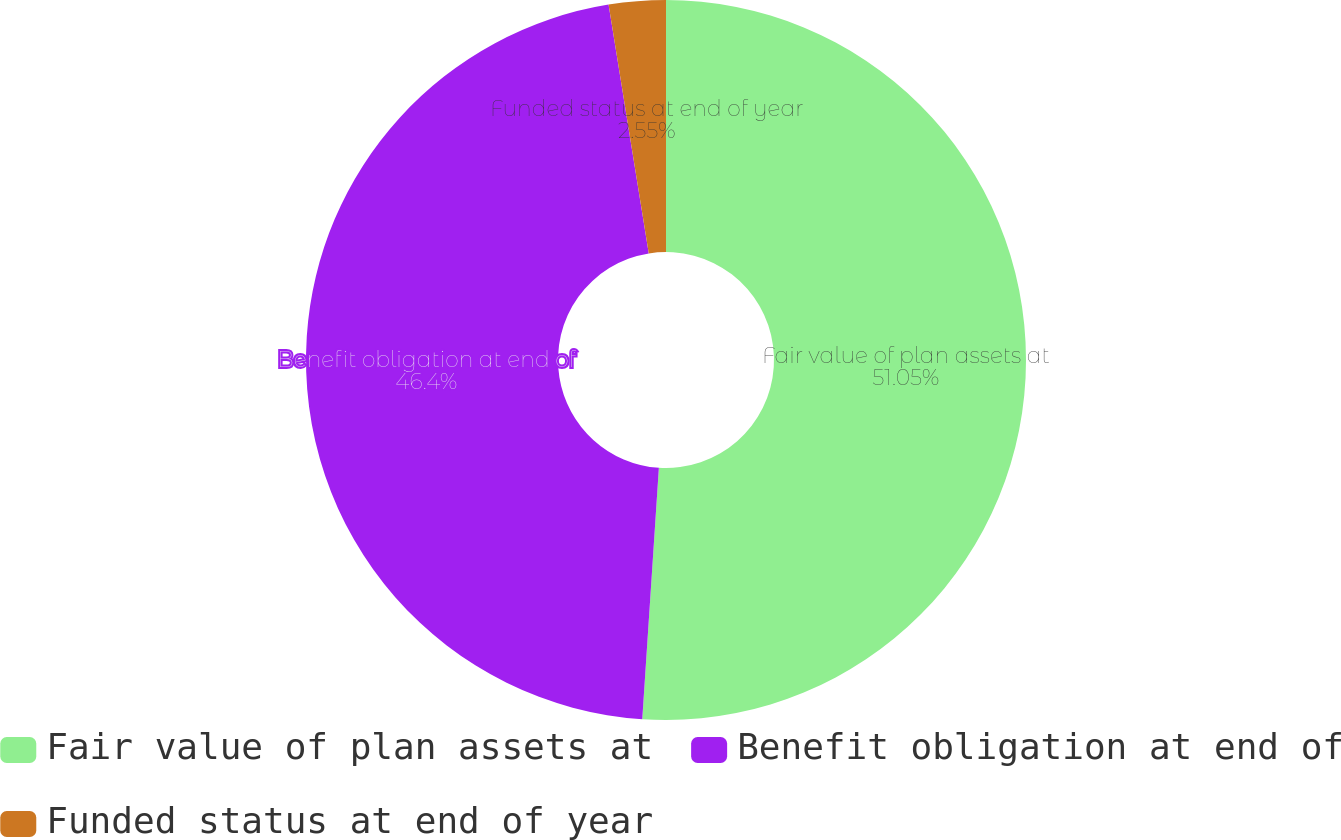<chart> <loc_0><loc_0><loc_500><loc_500><pie_chart><fcel>Fair value of plan assets at<fcel>Benefit obligation at end of<fcel>Funded status at end of year<nl><fcel>51.05%<fcel>46.4%<fcel>2.55%<nl></chart> 